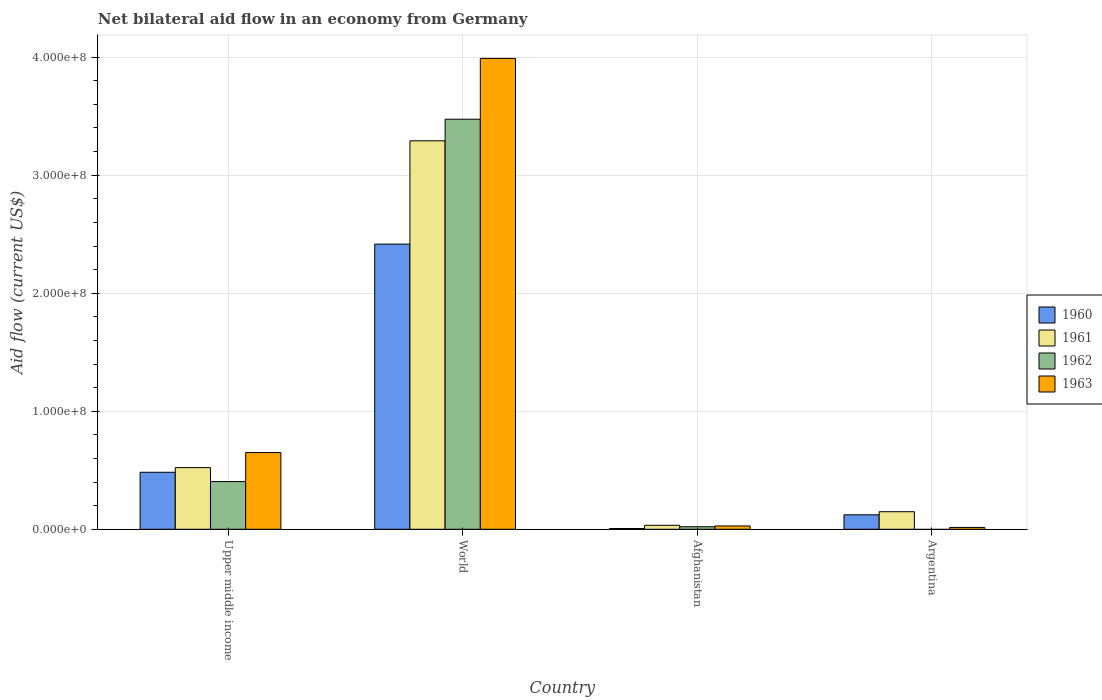Are the number of bars per tick equal to the number of legend labels?
Provide a short and direct response. No. How many bars are there on the 4th tick from the right?
Provide a succinct answer. 4. What is the net bilateral aid flow in 1961 in Argentina?
Ensure brevity in your answer.  1.49e+07. Across all countries, what is the maximum net bilateral aid flow in 1963?
Offer a terse response. 3.99e+08. Across all countries, what is the minimum net bilateral aid flow in 1961?
Give a very brief answer. 3.38e+06. In which country was the net bilateral aid flow in 1961 maximum?
Ensure brevity in your answer.  World. What is the total net bilateral aid flow in 1961 in the graph?
Make the answer very short. 4.00e+08. What is the difference between the net bilateral aid flow in 1961 in Afghanistan and that in Upper middle income?
Provide a short and direct response. -4.89e+07. What is the difference between the net bilateral aid flow in 1960 in Upper middle income and the net bilateral aid flow in 1961 in Afghanistan?
Provide a succinct answer. 4.49e+07. What is the average net bilateral aid flow in 1963 per country?
Ensure brevity in your answer.  1.17e+08. What is the difference between the net bilateral aid flow of/in 1960 and net bilateral aid flow of/in 1961 in Upper middle income?
Keep it short and to the point. -3.96e+06. In how many countries, is the net bilateral aid flow in 1962 greater than 320000000 US$?
Offer a very short reply. 1. What is the ratio of the net bilateral aid flow in 1961 in Argentina to that in Upper middle income?
Offer a terse response. 0.28. Is the net bilateral aid flow in 1963 in Argentina less than that in World?
Ensure brevity in your answer.  Yes. What is the difference between the highest and the second highest net bilateral aid flow in 1963?
Your answer should be very brief. 3.34e+08. What is the difference between the highest and the lowest net bilateral aid flow in 1960?
Offer a terse response. 2.41e+08. Is it the case that in every country, the sum of the net bilateral aid flow in 1960 and net bilateral aid flow in 1962 is greater than the sum of net bilateral aid flow in 1963 and net bilateral aid flow in 1961?
Keep it short and to the point. No. Is it the case that in every country, the sum of the net bilateral aid flow in 1962 and net bilateral aid flow in 1960 is greater than the net bilateral aid flow in 1963?
Ensure brevity in your answer.  No. How many bars are there?
Make the answer very short. 15. Are all the bars in the graph horizontal?
Provide a succinct answer. No. What is the difference between two consecutive major ticks on the Y-axis?
Keep it short and to the point. 1.00e+08. Are the values on the major ticks of Y-axis written in scientific E-notation?
Offer a very short reply. Yes. Does the graph contain any zero values?
Your response must be concise. Yes. Does the graph contain grids?
Make the answer very short. Yes. Where does the legend appear in the graph?
Provide a short and direct response. Center right. What is the title of the graph?
Give a very brief answer. Net bilateral aid flow in an economy from Germany. Does "2009" appear as one of the legend labels in the graph?
Offer a very short reply. No. What is the label or title of the X-axis?
Offer a terse response. Country. What is the label or title of the Y-axis?
Your answer should be compact. Aid flow (current US$). What is the Aid flow (current US$) of 1960 in Upper middle income?
Offer a terse response. 4.83e+07. What is the Aid flow (current US$) in 1961 in Upper middle income?
Offer a terse response. 5.22e+07. What is the Aid flow (current US$) of 1962 in Upper middle income?
Your response must be concise. 4.04e+07. What is the Aid flow (current US$) in 1963 in Upper middle income?
Make the answer very short. 6.50e+07. What is the Aid flow (current US$) of 1960 in World?
Offer a very short reply. 2.42e+08. What is the Aid flow (current US$) in 1961 in World?
Keep it short and to the point. 3.29e+08. What is the Aid flow (current US$) of 1962 in World?
Your answer should be compact. 3.47e+08. What is the Aid flow (current US$) in 1963 in World?
Keep it short and to the point. 3.99e+08. What is the Aid flow (current US$) of 1960 in Afghanistan?
Your answer should be compact. 6.50e+05. What is the Aid flow (current US$) in 1961 in Afghanistan?
Your answer should be very brief. 3.38e+06. What is the Aid flow (current US$) in 1962 in Afghanistan?
Keep it short and to the point. 2.15e+06. What is the Aid flow (current US$) in 1963 in Afghanistan?
Offer a terse response. 2.81e+06. What is the Aid flow (current US$) of 1960 in Argentina?
Offer a very short reply. 1.23e+07. What is the Aid flow (current US$) in 1961 in Argentina?
Provide a succinct answer. 1.49e+07. What is the Aid flow (current US$) of 1962 in Argentina?
Your answer should be very brief. 0. What is the Aid flow (current US$) in 1963 in Argentina?
Offer a terse response. 1.56e+06. Across all countries, what is the maximum Aid flow (current US$) in 1960?
Keep it short and to the point. 2.42e+08. Across all countries, what is the maximum Aid flow (current US$) of 1961?
Give a very brief answer. 3.29e+08. Across all countries, what is the maximum Aid flow (current US$) of 1962?
Make the answer very short. 3.47e+08. Across all countries, what is the maximum Aid flow (current US$) in 1963?
Provide a succinct answer. 3.99e+08. Across all countries, what is the minimum Aid flow (current US$) of 1960?
Your answer should be compact. 6.50e+05. Across all countries, what is the minimum Aid flow (current US$) in 1961?
Offer a terse response. 3.38e+06. Across all countries, what is the minimum Aid flow (current US$) in 1962?
Provide a succinct answer. 0. Across all countries, what is the minimum Aid flow (current US$) of 1963?
Make the answer very short. 1.56e+06. What is the total Aid flow (current US$) of 1960 in the graph?
Your answer should be compact. 3.03e+08. What is the total Aid flow (current US$) in 1961 in the graph?
Your answer should be compact. 4.00e+08. What is the total Aid flow (current US$) of 1962 in the graph?
Offer a terse response. 3.90e+08. What is the total Aid flow (current US$) in 1963 in the graph?
Give a very brief answer. 4.68e+08. What is the difference between the Aid flow (current US$) in 1960 in Upper middle income and that in World?
Keep it short and to the point. -1.93e+08. What is the difference between the Aid flow (current US$) of 1961 in Upper middle income and that in World?
Provide a succinct answer. -2.77e+08. What is the difference between the Aid flow (current US$) of 1962 in Upper middle income and that in World?
Make the answer very short. -3.07e+08. What is the difference between the Aid flow (current US$) of 1963 in Upper middle income and that in World?
Provide a short and direct response. -3.34e+08. What is the difference between the Aid flow (current US$) in 1960 in Upper middle income and that in Afghanistan?
Offer a terse response. 4.76e+07. What is the difference between the Aid flow (current US$) of 1961 in Upper middle income and that in Afghanistan?
Give a very brief answer. 4.89e+07. What is the difference between the Aid flow (current US$) in 1962 in Upper middle income and that in Afghanistan?
Provide a short and direct response. 3.82e+07. What is the difference between the Aid flow (current US$) in 1963 in Upper middle income and that in Afghanistan?
Ensure brevity in your answer.  6.22e+07. What is the difference between the Aid flow (current US$) in 1960 in Upper middle income and that in Argentina?
Offer a terse response. 3.60e+07. What is the difference between the Aid flow (current US$) of 1961 in Upper middle income and that in Argentina?
Provide a short and direct response. 3.74e+07. What is the difference between the Aid flow (current US$) of 1963 in Upper middle income and that in Argentina?
Your answer should be very brief. 6.34e+07. What is the difference between the Aid flow (current US$) in 1960 in World and that in Afghanistan?
Your answer should be compact. 2.41e+08. What is the difference between the Aid flow (current US$) in 1961 in World and that in Afghanistan?
Give a very brief answer. 3.26e+08. What is the difference between the Aid flow (current US$) of 1962 in World and that in Afghanistan?
Your response must be concise. 3.45e+08. What is the difference between the Aid flow (current US$) of 1963 in World and that in Afghanistan?
Provide a succinct answer. 3.96e+08. What is the difference between the Aid flow (current US$) of 1960 in World and that in Argentina?
Give a very brief answer. 2.29e+08. What is the difference between the Aid flow (current US$) of 1961 in World and that in Argentina?
Your answer should be compact. 3.14e+08. What is the difference between the Aid flow (current US$) of 1963 in World and that in Argentina?
Your answer should be very brief. 3.97e+08. What is the difference between the Aid flow (current US$) in 1960 in Afghanistan and that in Argentina?
Keep it short and to the point. -1.16e+07. What is the difference between the Aid flow (current US$) of 1961 in Afghanistan and that in Argentina?
Give a very brief answer. -1.15e+07. What is the difference between the Aid flow (current US$) in 1963 in Afghanistan and that in Argentina?
Keep it short and to the point. 1.25e+06. What is the difference between the Aid flow (current US$) in 1960 in Upper middle income and the Aid flow (current US$) in 1961 in World?
Provide a succinct answer. -2.81e+08. What is the difference between the Aid flow (current US$) in 1960 in Upper middle income and the Aid flow (current US$) in 1962 in World?
Provide a succinct answer. -2.99e+08. What is the difference between the Aid flow (current US$) in 1960 in Upper middle income and the Aid flow (current US$) in 1963 in World?
Your response must be concise. -3.51e+08. What is the difference between the Aid flow (current US$) in 1961 in Upper middle income and the Aid flow (current US$) in 1962 in World?
Your answer should be very brief. -2.95e+08. What is the difference between the Aid flow (current US$) in 1961 in Upper middle income and the Aid flow (current US$) in 1963 in World?
Your response must be concise. -3.47e+08. What is the difference between the Aid flow (current US$) of 1962 in Upper middle income and the Aid flow (current US$) of 1963 in World?
Make the answer very short. -3.59e+08. What is the difference between the Aid flow (current US$) in 1960 in Upper middle income and the Aid flow (current US$) in 1961 in Afghanistan?
Offer a terse response. 4.49e+07. What is the difference between the Aid flow (current US$) in 1960 in Upper middle income and the Aid flow (current US$) in 1962 in Afghanistan?
Provide a succinct answer. 4.61e+07. What is the difference between the Aid flow (current US$) in 1960 in Upper middle income and the Aid flow (current US$) in 1963 in Afghanistan?
Offer a very short reply. 4.55e+07. What is the difference between the Aid flow (current US$) in 1961 in Upper middle income and the Aid flow (current US$) in 1962 in Afghanistan?
Offer a terse response. 5.01e+07. What is the difference between the Aid flow (current US$) in 1961 in Upper middle income and the Aid flow (current US$) in 1963 in Afghanistan?
Provide a succinct answer. 4.94e+07. What is the difference between the Aid flow (current US$) in 1962 in Upper middle income and the Aid flow (current US$) in 1963 in Afghanistan?
Your answer should be very brief. 3.76e+07. What is the difference between the Aid flow (current US$) in 1960 in Upper middle income and the Aid flow (current US$) in 1961 in Argentina?
Keep it short and to the point. 3.34e+07. What is the difference between the Aid flow (current US$) in 1960 in Upper middle income and the Aid flow (current US$) in 1963 in Argentina?
Ensure brevity in your answer.  4.67e+07. What is the difference between the Aid flow (current US$) of 1961 in Upper middle income and the Aid flow (current US$) of 1963 in Argentina?
Offer a very short reply. 5.07e+07. What is the difference between the Aid flow (current US$) of 1962 in Upper middle income and the Aid flow (current US$) of 1963 in Argentina?
Provide a short and direct response. 3.88e+07. What is the difference between the Aid flow (current US$) of 1960 in World and the Aid flow (current US$) of 1961 in Afghanistan?
Your answer should be compact. 2.38e+08. What is the difference between the Aid flow (current US$) in 1960 in World and the Aid flow (current US$) in 1962 in Afghanistan?
Ensure brevity in your answer.  2.39e+08. What is the difference between the Aid flow (current US$) of 1960 in World and the Aid flow (current US$) of 1963 in Afghanistan?
Your answer should be compact. 2.39e+08. What is the difference between the Aid flow (current US$) in 1961 in World and the Aid flow (current US$) in 1962 in Afghanistan?
Provide a succinct answer. 3.27e+08. What is the difference between the Aid flow (current US$) of 1961 in World and the Aid flow (current US$) of 1963 in Afghanistan?
Provide a short and direct response. 3.26e+08. What is the difference between the Aid flow (current US$) of 1962 in World and the Aid flow (current US$) of 1963 in Afghanistan?
Offer a terse response. 3.45e+08. What is the difference between the Aid flow (current US$) of 1960 in World and the Aid flow (current US$) of 1961 in Argentina?
Give a very brief answer. 2.27e+08. What is the difference between the Aid flow (current US$) in 1960 in World and the Aid flow (current US$) in 1963 in Argentina?
Your answer should be compact. 2.40e+08. What is the difference between the Aid flow (current US$) of 1961 in World and the Aid flow (current US$) of 1963 in Argentina?
Make the answer very short. 3.28e+08. What is the difference between the Aid flow (current US$) in 1962 in World and the Aid flow (current US$) in 1963 in Argentina?
Make the answer very short. 3.46e+08. What is the difference between the Aid flow (current US$) of 1960 in Afghanistan and the Aid flow (current US$) of 1961 in Argentina?
Provide a short and direct response. -1.42e+07. What is the difference between the Aid flow (current US$) of 1960 in Afghanistan and the Aid flow (current US$) of 1963 in Argentina?
Provide a short and direct response. -9.10e+05. What is the difference between the Aid flow (current US$) of 1961 in Afghanistan and the Aid flow (current US$) of 1963 in Argentina?
Provide a short and direct response. 1.82e+06. What is the difference between the Aid flow (current US$) of 1962 in Afghanistan and the Aid flow (current US$) of 1963 in Argentina?
Make the answer very short. 5.90e+05. What is the average Aid flow (current US$) of 1960 per country?
Offer a very short reply. 7.57e+07. What is the average Aid flow (current US$) of 1961 per country?
Your answer should be compact. 9.99e+07. What is the average Aid flow (current US$) in 1962 per country?
Offer a terse response. 9.75e+07. What is the average Aid flow (current US$) in 1963 per country?
Your response must be concise. 1.17e+08. What is the difference between the Aid flow (current US$) in 1960 and Aid flow (current US$) in 1961 in Upper middle income?
Your answer should be very brief. -3.96e+06. What is the difference between the Aid flow (current US$) of 1960 and Aid flow (current US$) of 1962 in Upper middle income?
Your response must be concise. 7.89e+06. What is the difference between the Aid flow (current US$) in 1960 and Aid flow (current US$) in 1963 in Upper middle income?
Your answer should be compact. -1.67e+07. What is the difference between the Aid flow (current US$) of 1961 and Aid flow (current US$) of 1962 in Upper middle income?
Offer a very short reply. 1.18e+07. What is the difference between the Aid flow (current US$) of 1961 and Aid flow (current US$) of 1963 in Upper middle income?
Keep it short and to the point. -1.28e+07. What is the difference between the Aid flow (current US$) in 1962 and Aid flow (current US$) in 1963 in Upper middle income?
Provide a short and direct response. -2.46e+07. What is the difference between the Aid flow (current US$) of 1960 and Aid flow (current US$) of 1961 in World?
Make the answer very short. -8.75e+07. What is the difference between the Aid flow (current US$) of 1960 and Aid flow (current US$) of 1962 in World?
Keep it short and to the point. -1.06e+08. What is the difference between the Aid flow (current US$) in 1960 and Aid flow (current US$) in 1963 in World?
Offer a very short reply. -1.57e+08. What is the difference between the Aid flow (current US$) in 1961 and Aid flow (current US$) in 1962 in World?
Provide a succinct answer. -1.83e+07. What is the difference between the Aid flow (current US$) of 1961 and Aid flow (current US$) of 1963 in World?
Provide a succinct answer. -6.98e+07. What is the difference between the Aid flow (current US$) in 1962 and Aid flow (current US$) in 1963 in World?
Provide a succinct answer. -5.15e+07. What is the difference between the Aid flow (current US$) in 1960 and Aid flow (current US$) in 1961 in Afghanistan?
Ensure brevity in your answer.  -2.73e+06. What is the difference between the Aid flow (current US$) of 1960 and Aid flow (current US$) of 1962 in Afghanistan?
Ensure brevity in your answer.  -1.50e+06. What is the difference between the Aid flow (current US$) of 1960 and Aid flow (current US$) of 1963 in Afghanistan?
Make the answer very short. -2.16e+06. What is the difference between the Aid flow (current US$) of 1961 and Aid flow (current US$) of 1962 in Afghanistan?
Your answer should be compact. 1.23e+06. What is the difference between the Aid flow (current US$) of 1961 and Aid flow (current US$) of 1963 in Afghanistan?
Your answer should be very brief. 5.70e+05. What is the difference between the Aid flow (current US$) of 1962 and Aid flow (current US$) of 1963 in Afghanistan?
Your answer should be compact. -6.60e+05. What is the difference between the Aid flow (current US$) in 1960 and Aid flow (current US$) in 1961 in Argentina?
Your answer should be compact. -2.62e+06. What is the difference between the Aid flow (current US$) in 1960 and Aid flow (current US$) in 1963 in Argentina?
Your answer should be compact. 1.07e+07. What is the difference between the Aid flow (current US$) in 1961 and Aid flow (current US$) in 1963 in Argentina?
Give a very brief answer. 1.33e+07. What is the ratio of the Aid flow (current US$) of 1960 in Upper middle income to that in World?
Keep it short and to the point. 0.2. What is the ratio of the Aid flow (current US$) in 1961 in Upper middle income to that in World?
Your answer should be very brief. 0.16. What is the ratio of the Aid flow (current US$) in 1962 in Upper middle income to that in World?
Give a very brief answer. 0.12. What is the ratio of the Aid flow (current US$) of 1963 in Upper middle income to that in World?
Your answer should be very brief. 0.16. What is the ratio of the Aid flow (current US$) of 1960 in Upper middle income to that in Afghanistan?
Give a very brief answer. 74.29. What is the ratio of the Aid flow (current US$) in 1961 in Upper middle income to that in Afghanistan?
Your answer should be very brief. 15.46. What is the ratio of the Aid flow (current US$) of 1962 in Upper middle income to that in Afghanistan?
Provide a short and direct response. 18.79. What is the ratio of the Aid flow (current US$) of 1963 in Upper middle income to that in Afghanistan?
Give a very brief answer. 23.13. What is the ratio of the Aid flow (current US$) in 1960 in Upper middle income to that in Argentina?
Offer a very short reply. 3.94. What is the ratio of the Aid flow (current US$) in 1961 in Upper middle income to that in Argentina?
Your response must be concise. 3.51. What is the ratio of the Aid flow (current US$) of 1963 in Upper middle income to that in Argentina?
Offer a very short reply. 41.67. What is the ratio of the Aid flow (current US$) in 1960 in World to that in Afghanistan?
Offer a very short reply. 371.71. What is the ratio of the Aid flow (current US$) in 1961 in World to that in Afghanistan?
Offer a very short reply. 97.38. What is the ratio of the Aid flow (current US$) in 1962 in World to that in Afghanistan?
Offer a terse response. 161.59. What is the ratio of the Aid flow (current US$) in 1963 in World to that in Afghanistan?
Offer a very short reply. 141.97. What is the ratio of the Aid flow (current US$) of 1960 in World to that in Argentina?
Offer a terse response. 19.71. What is the ratio of the Aid flow (current US$) in 1961 in World to that in Argentina?
Your answer should be very brief. 22.12. What is the ratio of the Aid flow (current US$) in 1963 in World to that in Argentina?
Offer a very short reply. 255.72. What is the ratio of the Aid flow (current US$) of 1960 in Afghanistan to that in Argentina?
Make the answer very short. 0.05. What is the ratio of the Aid flow (current US$) of 1961 in Afghanistan to that in Argentina?
Ensure brevity in your answer.  0.23. What is the ratio of the Aid flow (current US$) of 1963 in Afghanistan to that in Argentina?
Your answer should be very brief. 1.8. What is the difference between the highest and the second highest Aid flow (current US$) of 1960?
Provide a short and direct response. 1.93e+08. What is the difference between the highest and the second highest Aid flow (current US$) in 1961?
Offer a terse response. 2.77e+08. What is the difference between the highest and the second highest Aid flow (current US$) in 1962?
Offer a terse response. 3.07e+08. What is the difference between the highest and the second highest Aid flow (current US$) of 1963?
Offer a very short reply. 3.34e+08. What is the difference between the highest and the lowest Aid flow (current US$) of 1960?
Give a very brief answer. 2.41e+08. What is the difference between the highest and the lowest Aid flow (current US$) in 1961?
Your answer should be compact. 3.26e+08. What is the difference between the highest and the lowest Aid flow (current US$) in 1962?
Ensure brevity in your answer.  3.47e+08. What is the difference between the highest and the lowest Aid flow (current US$) of 1963?
Ensure brevity in your answer.  3.97e+08. 